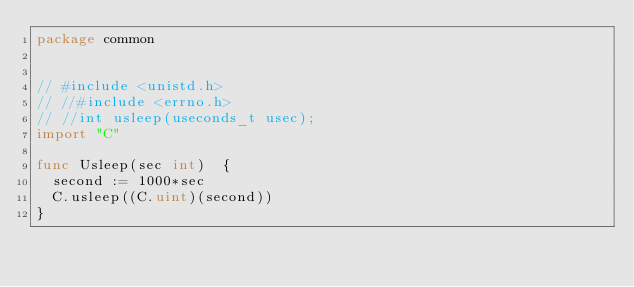Convert code to text. <code><loc_0><loc_0><loc_500><loc_500><_Go_>package common


// #include <unistd.h>
// //#include <errno.h>
// //int usleep(useconds_t usec);
import "C"

func Usleep(sec int)  {
	second := 1000*sec
	C.usleep((C.uint)(second))
}
</code> 